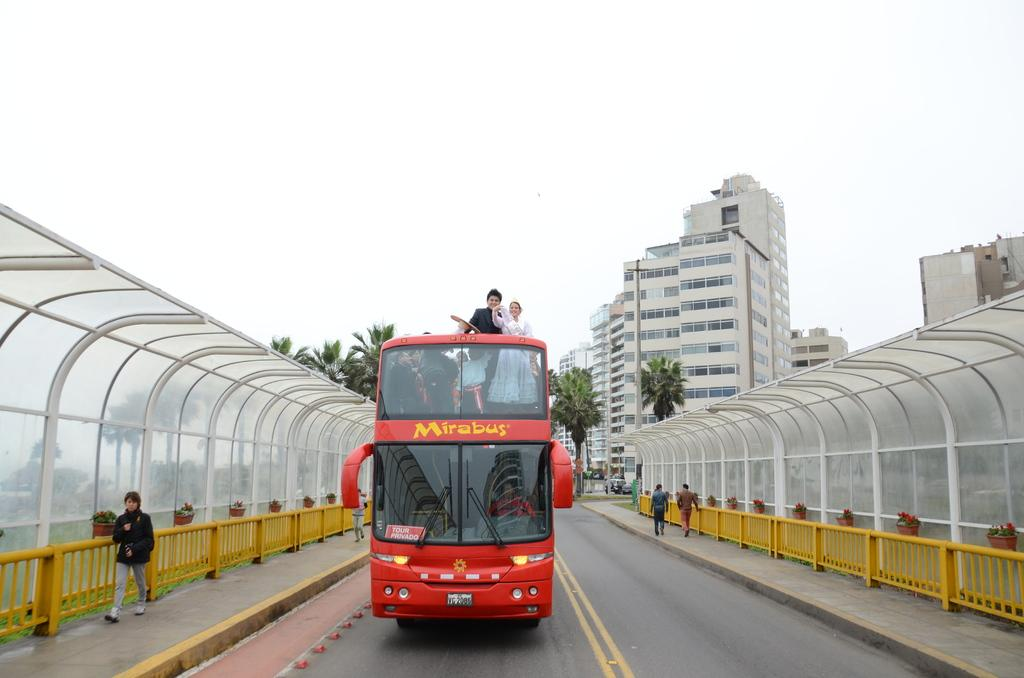<image>
Write a terse but informative summary of the picture. The red Mirabus drives on a bridge bordered in yellow fencing. 